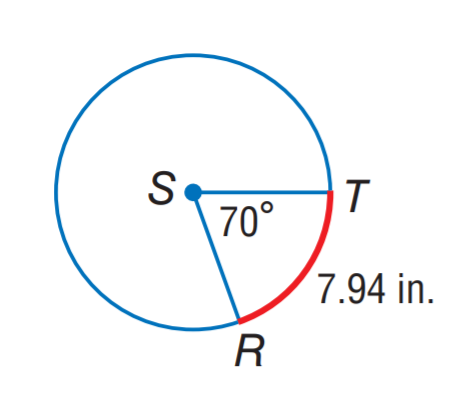Question: Find the circumference of \odot S. Round to the nearest hundredth.
Choices:
A. 7.94
B. 20.42
C. 40.83
D. 81.67
Answer with the letter. Answer: C 